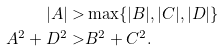Convert formula to latex. <formula><loc_0><loc_0><loc_500><loc_500>| A | > & \max \{ | B | , | C | , | D | \} \\ A ^ { 2 } + D ^ { 2 } > & B ^ { 2 } + C ^ { 2 } .</formula> 